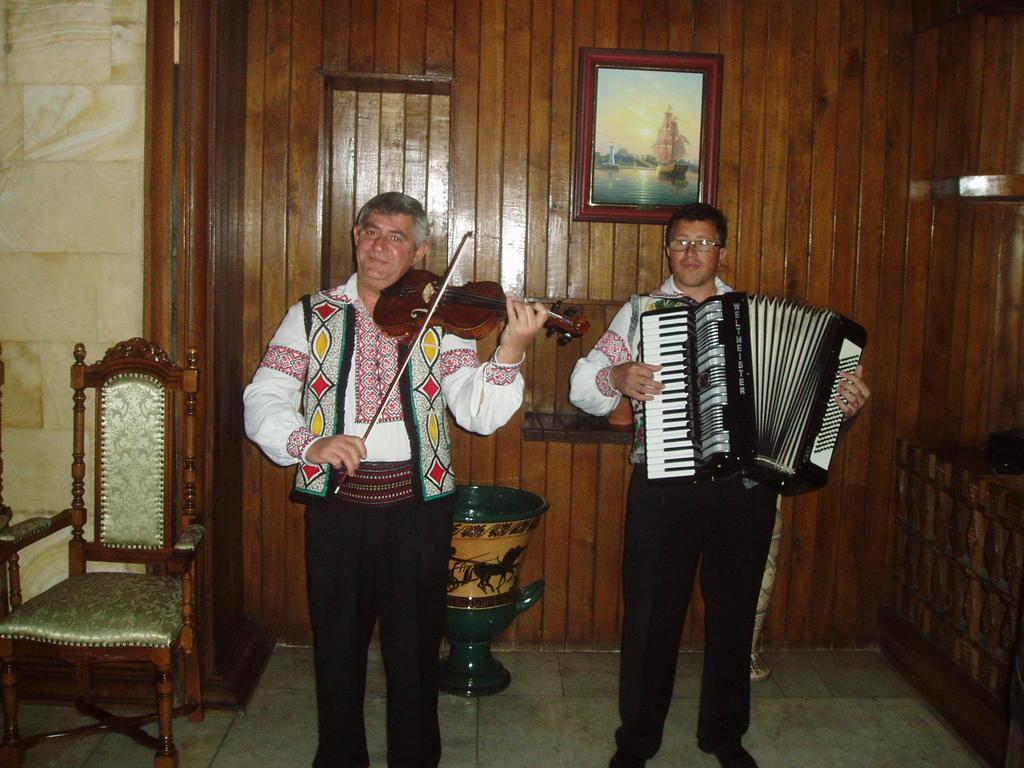In one or two sentences, can you explain what this image depicts? This is a picture where we have two people playing different musical instruments and behind them there is a wooden wall on which there is a photo frame and beside the person there is a wooden chair. 